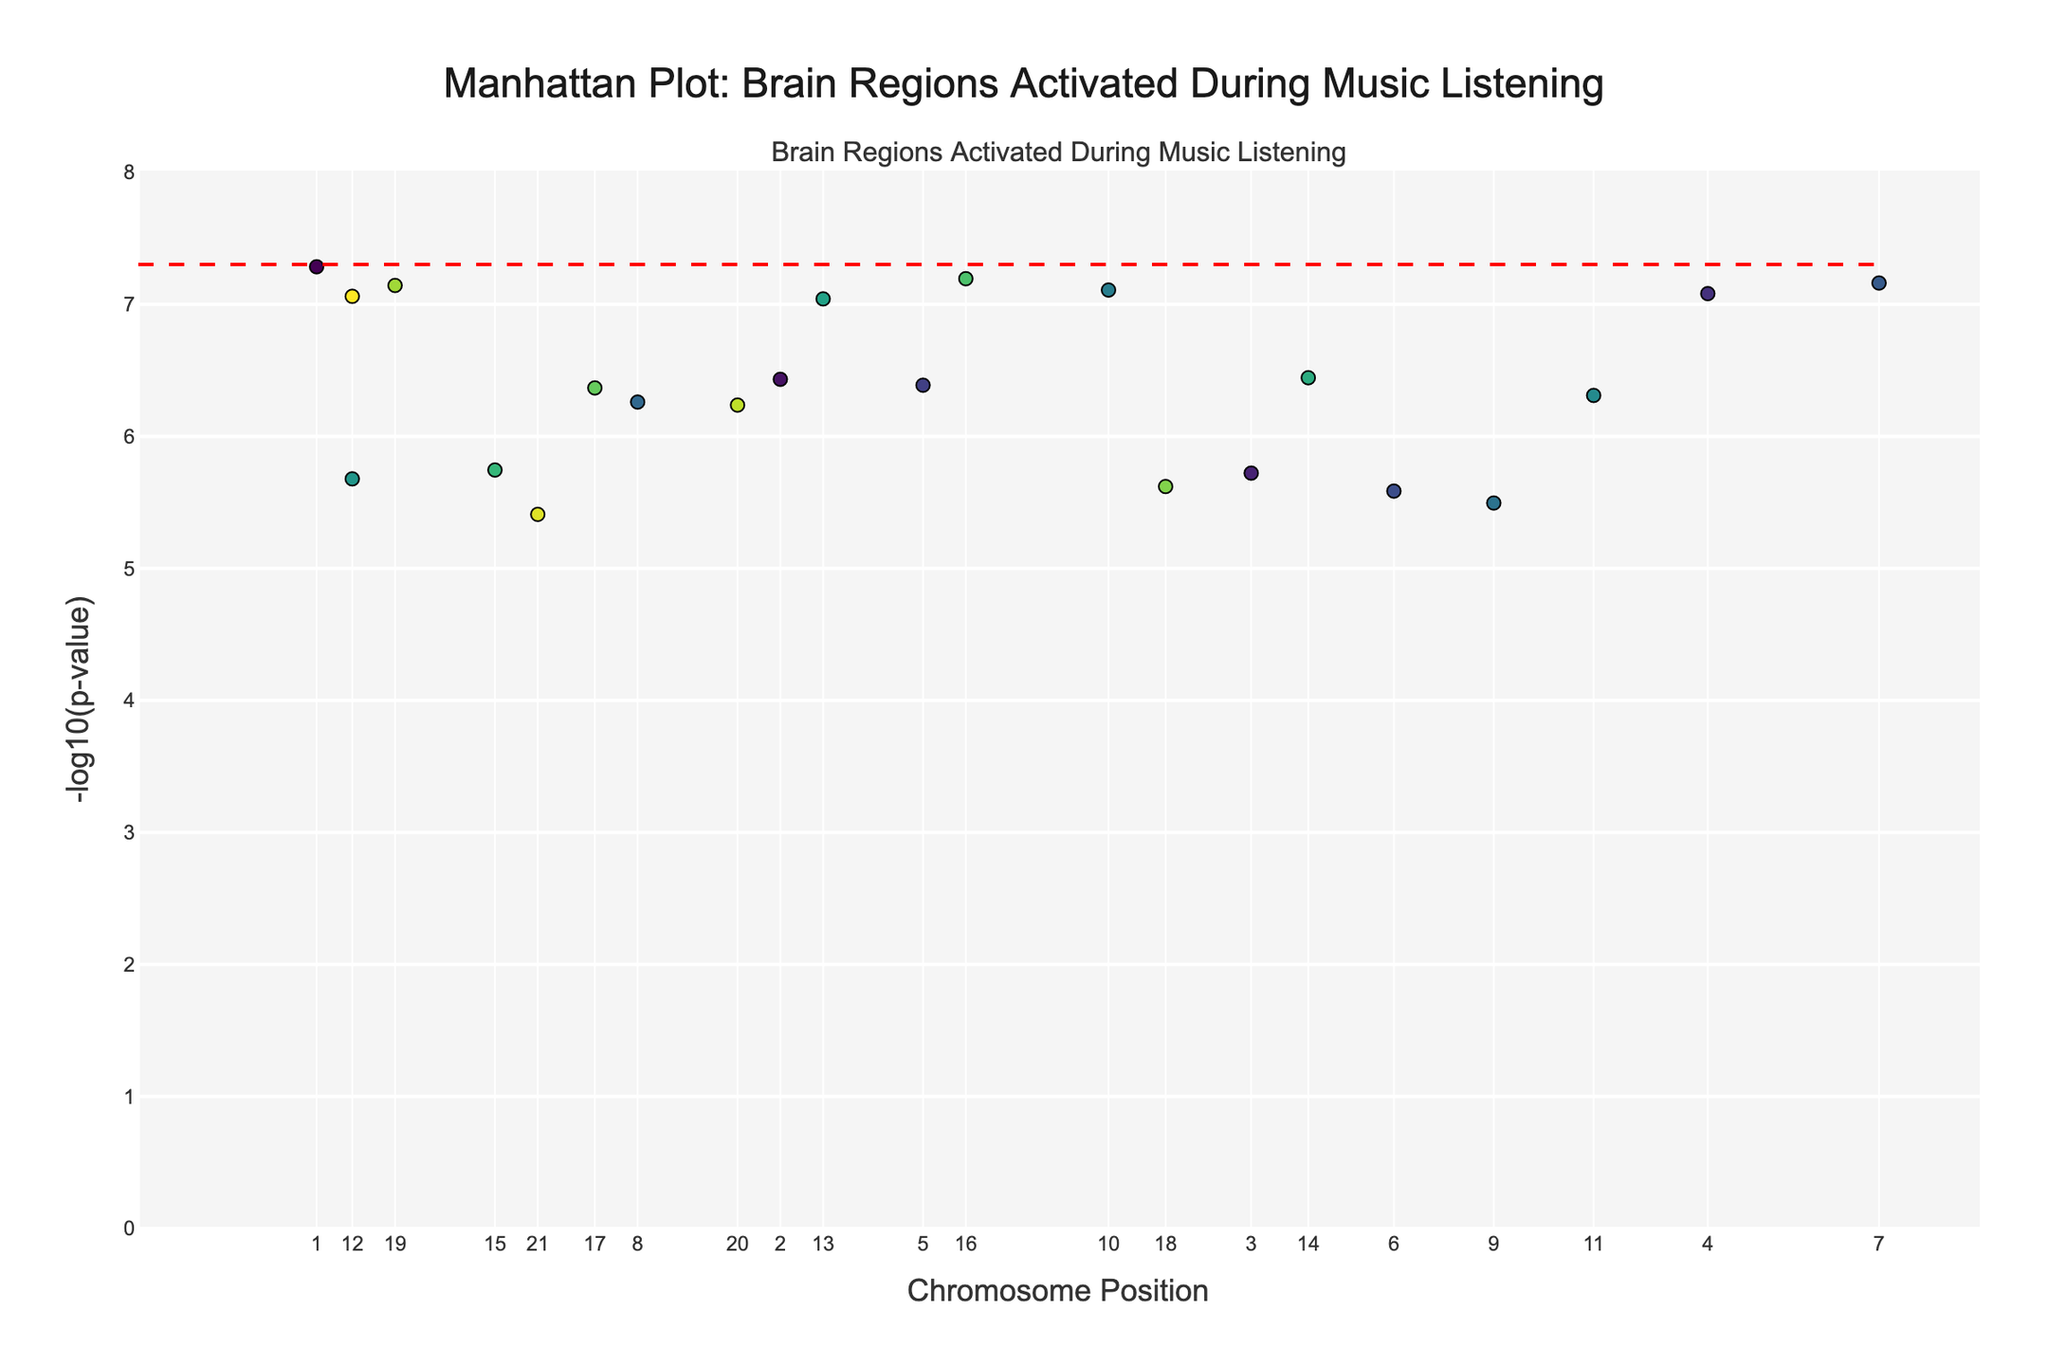What is the title of the figure? The title can be seen at the top of the figure. It summarizes the content depicted in the plot.
Answer: Manhattan Plot: Brain Regions Activated During Music Listening How many brain regions have a -log10(p-value) greater than 7? To find this, count all the points on the y-axis whose -log10(p-value) is above 7.
Answer: 8 Which brain region is associated with the 10th chromosome? Look at the position where the 10th chromosome value is indicated and read the corresponding brain region from the plot's data points.
Answer: Premotor cortex What brain region shows the lowest p-value? The brain region with the highest point on the y-axis (largest -log10(p-value)) will have the lowest p-value.
Answer: Superior temporal gyrus Which chromosome has the brain region with the highest significance activation? Find the peak point on the y-axis, and check the chromosome associated with that point.
Answer: Chromosome 1 Compare the -log10(p-value) of the Inferior frontal gyrus and Anterior cingulate cortex. Which one is higher? Locate the points for Inferior frontal gyrus and Anterior cingulate cortex, then compare their heights on the y-axis (-log10(p-value)).
Answer: Inferior frontal gyrus What is the chromosome position with the highest significance (lowest p-value)? The highest significance corresponds to the highest point on the y-axis. Cross-reference it with the x-axis to find its position.
Answer: 12500000 Identify the brain region with the significance threshold line -log10(p-value) = 7.3. The red dashed line represents the threshold -log10(p-value). Locate the point that aligns closely with this line to identify the brain region.
Answer: Superior temporal gyrus Which region shows significant activation in the cerebellum? Find the brain region listed as 'Cerebellum' and check its position on the plot to see if it falls above the significance threshold.
Answer: Yes 